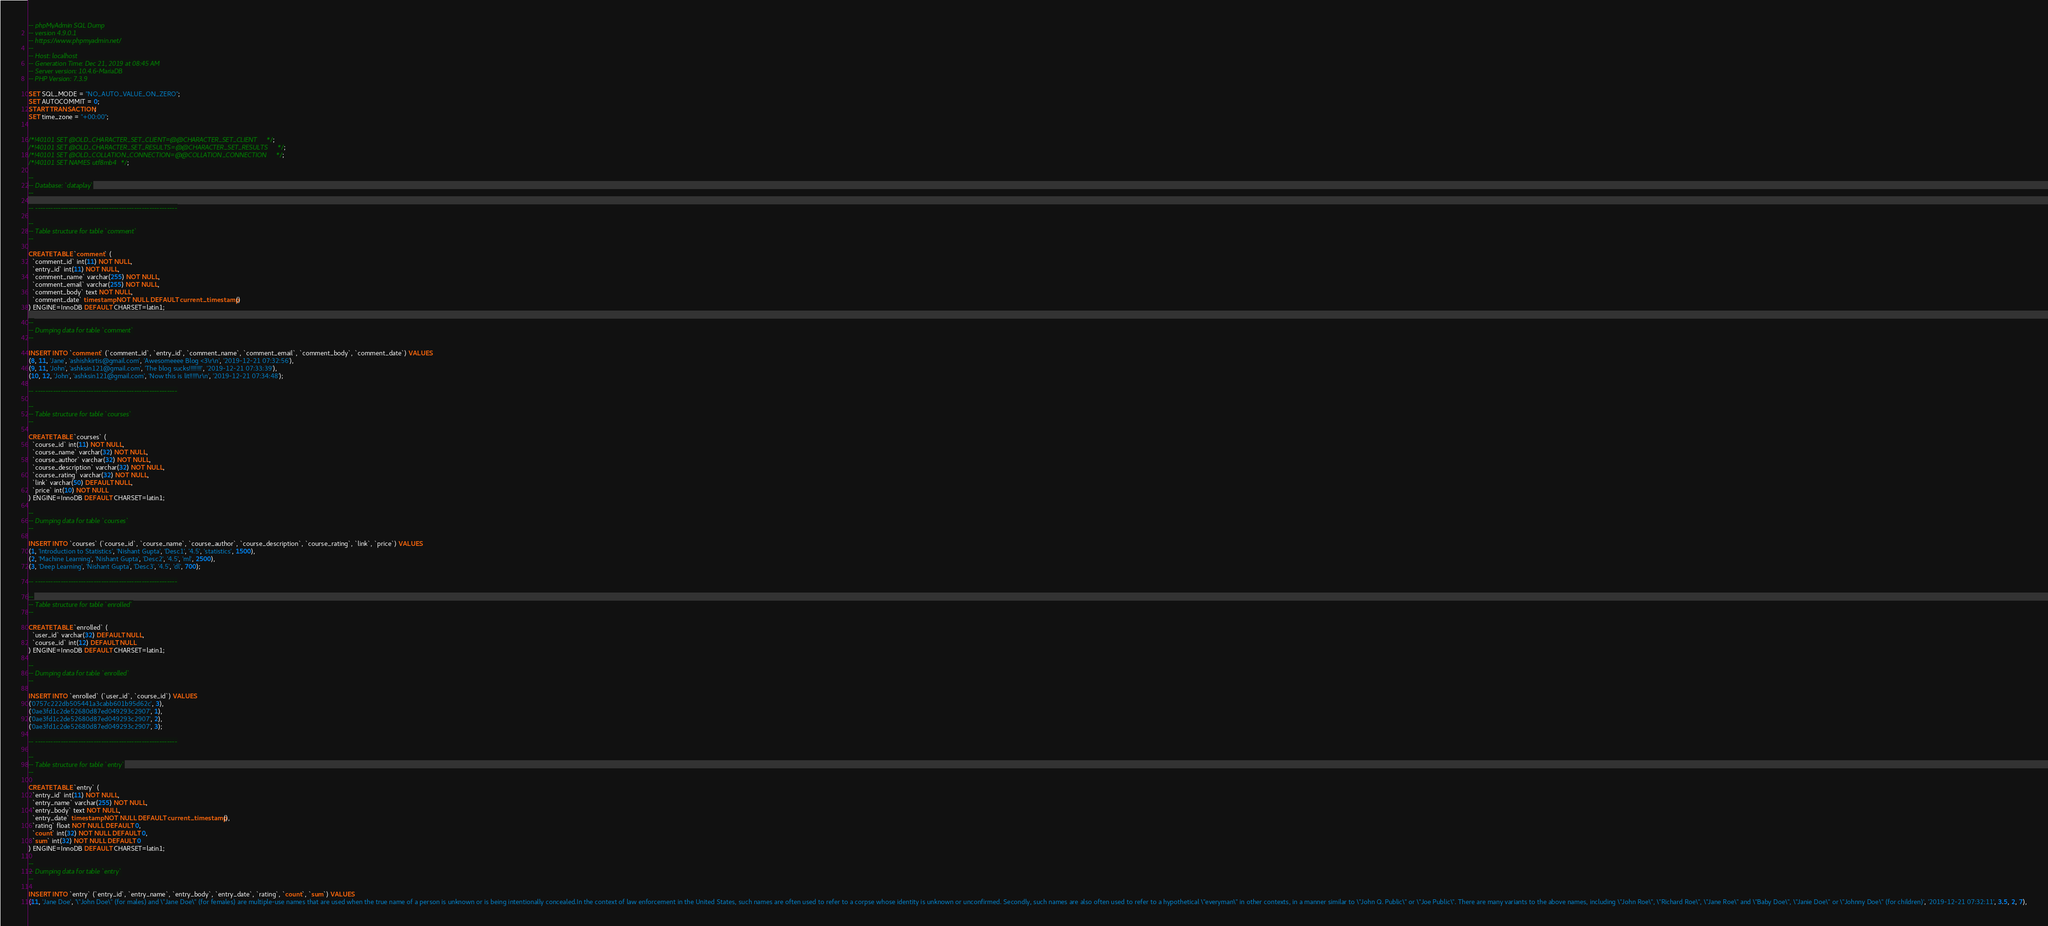<code> <loc_0><loc_0><loc_500><loc_500><_SQL_>-- phpMyAdmin SQL Dump
-- version 4.9.0.1
-- https://www.phpmyadmin.net/
--
-- Host: localhost
-- Generation Time: Dec 21, 2019 at 08:45 AM
-- Server version: 10.4.6-MariaDB
-- PHP Version: 7.3.9

SET SQL_MODE = "NO_AUTO_VALUE_ON_ZERO";
SET AUTOCOMMIT = 0;
START TRANSACTION;
SET time_zone = "+00:00";


/*!40101 SET @OLD_CHARACTER_SET_CLIENT=@@CHARACTER_SET_CLIENT */;
/*!40101 SET @OLD_CHARACTER_SET_RESULTS=@@CHARACTER_SET_RESULTS */;
/*!40101 SET @OLD_COLLATION_CONNECTION=@@COLLATION_CONNECTION */;
/*!40101 SET NAMES utf8mb4 */;

--
-- Database: `dataplay`
--

-- --------------------------------------------------------

--
-- Table structure for table `comment`
--

CREATE TABLE `comment` (
  `comment_id` int(11) NOT NULL,
  `entry_id` int(11) NOT NULL,
  `comment_name` varchar(255) NOT NULL,
  `comment_email` varchar(255) NOT NULL,
  `comment_body` text NOT NULL,
  `comment_date` timestamp NOT NULL DEFAULT current_timestamp()
) ENGINE=InnoDB DEFAULT CHARSET=latin1;

--
-- Dumping data for table `comment`
--

INSERT INTO `comment` (`comment_id`, `entry_id`, `comment_name`, `comment_email`, `comment_body`, `comment_date`) VALUES
(8, 11, 'Jane', 'ashishkirtis@gmail.com', 'Awesomeeee Blog <3\r\n', '2019-12-21 07:32:56'),
(9, 11, 'John', 'ashksin121@gmail.com', 'The blog sucks!!!!!!!!', '2019-12-21 07:33:39'),
(10, 12, 'John', 'ashksin121@gmail.com', 'Now this is lit!!!!!\r\n', '2019-12-21 07:34:48');

-- --------------------------------------------------------

--
-- Table structure for table `courses`
--

CREATE TABLE `courses` (
  `course_id` int(11) NOT NULL,
  `course_name` varchar(32) NOT NULL,
  `course_author` varchar(32) NOT NULL,
  `course_description` varchar(32) NOT NULL,
  `course_rating` varchar(32) NOT NULL,
  `link` varchar(50) DEFAULT NULL,
  `price` int(10) NOT NULL
) ENGINE=InnoDB DEFAULT CHARSET=latin1;

--
-- Dumping data for table `courses`
--

INSERT INTO `courses` (`course_id`, `course_name`, `course_author`, `course_description`, `course_rating`, `link`, `price`) VALUES
(1, 'Introduction to Statistics', 'Nishant Gupta', 'Desc1', '4.5', 'statistics', 1500),
(2, 'Machine Learning', 'Nishant Gupta', 'Desc2', '4.5', 'ml', 2500),
(3, 'Deep Learning', 'Nishant Gupta', 'Desc3', '4.5', 'dl', 700);

-- --------------------------------------------------------

--
-- Table structure for table `enrolled`
--

CREATE TABLE `enrolled` (
  `user_id` varchar(32) DEFAULT NULL,
  `course_id` int(12) DEFAULT NULL
) ENGINE=InnoDB DEFAULT CHARSET=latin1;

--
-- Dumping data for table `enrolled`
--

INSERT INTO `enrolled` (`user_id`, `course_id`) VALUES
('0757c222db505441a3cabb601b95d62c', 3),
('0ae3fd1c2de52680d87ed049293c2907', 1),
('0ae3fd1c2de52680d87ed049293c2907', 2),
('0ae3fd1c2de52680d87ed049293c2907', 3);

-- --------------------------------------------------------

--
-- Table structure for table `entry`
--

CREATE TABLE `entry` (
  `entry_id` int(11) NOT NULL,
  `entry_name` varchar(255) NOT NULL,
  `entry_body` text NOT NULL,
  `entry_date` timestamp NOT NULL DEFAULT current_timestamp(),
  `rating` float NOT NULL DEFAULT 0,
  `count` int(32) NOT NULL DEFAULT 0,
  `sum` int(32) NOT NULL DEFAULT 0
) ENGINE=InnoDB DEFAULT CHARSET=latin1;

--
-- Dumping data for table `entry`
--

INSERT INTO `entry` (`entry_id`, `entry_name`, `entry_body`, `entry_date`, `rating`, `count`, `sum`) VALUES
(11, 'Jane Doe', '\"John Doe\" (for males) and \"Jane Doe\" (for females) are multiple-use names that are used when the true name of a person is unknown or is being intentionally concealed.In the context of law enforcement in the United States, such names are often used to refer to a corpse whose identity is unknown or unconfirmed. Secondly, such names are also often used to refer to a hypothetical \"everyman\" in other contexts, in a manner similar to \"John Q. Public\" or \"Joe Public\". There are many variants to the above names, including \"John Roe\", \"Richard Roe\", \"Jane Roe\" and \"Baby Doe\", \"Janie Doe\" or \"Johnny Doe\" (for children)', '2019-12-21 07:32:11', 3.5, 2, 7),</code> 